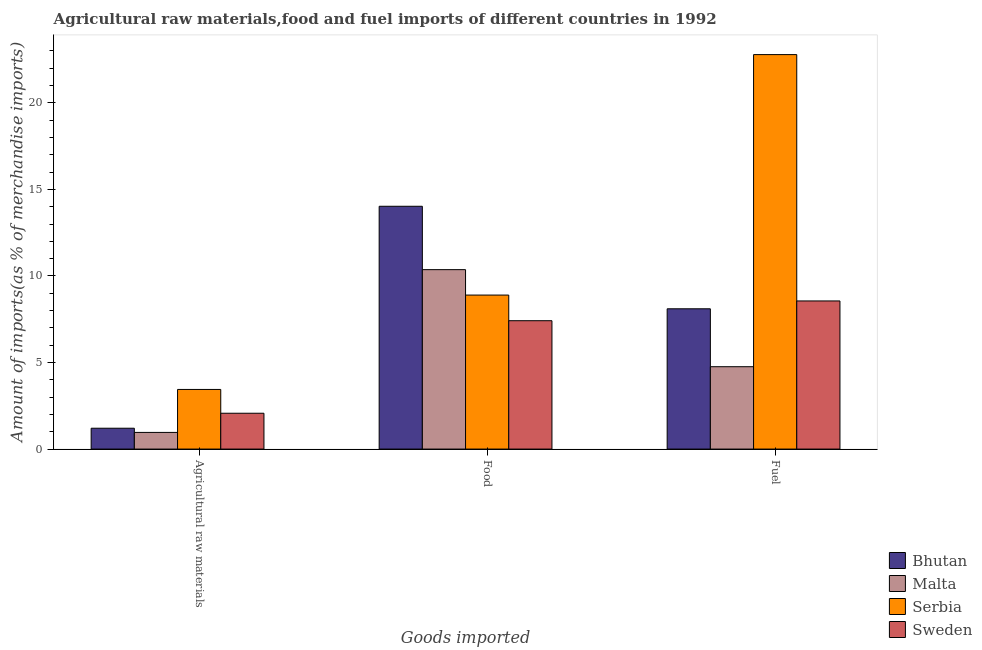How many different coloured bars are there?
Ensure brevity in your answer.  4. How many groups of bars are there?
Make the answer very short. 3. How many bars are there on the 2nd tick from the left?
Provide a succinct answer. 4. How many bars are there on the 3rd tick from the right?
Your response must be concise. 4. What is the label of the 2nd group of bars from the left?
Provide a succinct answer. Food. What is the percentage of raw materials imports in Sweden?
Your answer should be compact. 2.07. Across all countries, what is the maximum percentage of food imports?
Provide a short and direct response. 14.03. Across all countries, what is the minimum percentage of fuel imports?
Your answer should be very brief. 4.76. In which country was the percentage of fuel imports maximum?
Your response must be concise. Serbia. In which country was the percentage of raw materials imports minimum?
Provide a short and direct response. Malta. What is the total percentage of food imports in the graph?
Provide a succinct answer. 40.7. What is the difference between the percentage of fuel imports in Serbia and that in Sweden?
Your answer should be compact. 14.23. What is the difference between the percentage of raw materials imports in Sweden and the percentage of fuel imports in Malta?
Your response must be concise. -2.69. What is the average percentage of raw materials imports per country?
Give a very brief answer. 1.92. What is the difference between the percentage of food imports and percentage of raw materials imports in Serbia?
Your answer should be very brief. 5.45. In how many countries, is the percentage of fuel imports greater than 19 %?
Your response must be concise. 1. What is the ratio of the percentage of food imports in Sweden to that in Bhutan?
Ensure brevity in your answer.  0.53. What is the difference between the highest and the second highest percentage of food imports?
Offer a terse response. 3.66. What is the difference between the highest and the lowest percentage of fuel imports?
Your answer should be very brief. 18.03. Is the sum of the percentage of food imports in Sweden and Bhutan greater than the maximum percentage of raw materials imports across all countries?
Ensure brevity in your answer.  Yes. What does the 3rd bar from the left in Agricultural raw materials represents?
Make the answer very short. Serbia. What does the 3rd bar from the right in Fuel represents?
Provide a short and direct response. Malta. Is it the case that in every country, the sum of the percentage of raw materials imports and percentage of food imports is greater than the percentage of fuel imports?
Your response must be concise. No. How many bars are there?
Make the answer very short. 12. How many countries are there in the graph?
Offer a terse response. 4. Are the values on the major ticks of Y-axis written in scientific E-notation?
Provide a succinct answer. No. How many legend labels are there?
Provide a short and direct response. 4. What is the title of the graph?
Offer a very short reply. Agricultural raw materials,food and fuel imports of different countries in 1992. Does "Europe(developing only)" appear as one of the legend labels in the graph?
Ensure brevity in your answer.  No. What is the label or title of the X-axis?
Make the answer very short. Goods imported. What is the label or title of the Y-axis?
Your response must be concise. Amount of imports(as % of merchandise imports). What is the Amount of imports(as % of merchandise imports) of Bhutan in Agricultural raw materials?
Your answer should be very brief. 1.2. What is the Amount of imports(as % of merchandise imports) of Malta in Agricultural raw materials?
Ensure brevity in your answer.  0.96. What is the Amount of imports(as % of merchandise imports) in Serbia in Agricultural raw materials?
Provide a short and direct response. 3.44. What is the Amount of imports(as % of merchandise imports) in Sweden in Agricultural raw materials?
Ensure brevity in your answer.  2.07. What is the Amount of imports(as % of merchandise imports) in Bhutan in Food?
Offer a terse response. 14.03. What is the Amount of imports(as % of merchandise imports) in Malta in Food?
Give a very brief answer. 10.36. What is the Amount of imports(as % of merchandise imports) in Serbia in Food?
Make the answer very short. 8.9. What is the Amount of imports(as % of merchandise imports) of Sweden in Food?
Ensure brevity in your answer.  7.42. What is the Amount of imports(as % of merchandise imports) in Bhutan in Fuel?
Your response must be concise. 8.1. What is the Amount of imports(as % of merchandise imports) in Malta in Fuel?
Provide a succinct answer. 4.76. What is the Amount of imports(as % of merchandise imports) in Serbia in Fuel?
Ensure brevity in your answer.  22.79. What is the Amount of imports(as % of merchandise imports) in Sweden in Fuel?
Provide a succinct answer. 8.56. Across all Goods imported, what is the maximum Amount of imports(as % of merchandise imports) in Bhutan?
Your answer should be compact. 14.03. Across all Goods imported, what is the maximum Amount of imports(as % of merchandise imports) of Malta?
Provide a short and direct response. 10.36. Across all Goods imported, what is the maximum Amount of imports(as % of merchandise imports) in Serbia?
Keep it short and to the point. 22.79. Across all Goods imported, what is the maximum Amount of imports(as % of merchandise imports) in Sweden?
Ensure brevity in your answer.  8.56. Across all Goods imported, what is the minimum Amount of imports(as % of merchandise imports) in Bhutan?
Ensure brevity in your answer.  1.2. Across all Goods imported, what is the minimum Amount of imports(as % of merchandise imports) of Malta?
Keep it short and to the point. 0.96. Across all Goods imported, what is the minimum Amount of imports(as % of merchandise imports) of Serbia?
Make the answer very short. 3.44. Across all Goods imported, what is the minimum Amount of imports(as % of merchandise imports) of Sweden?
Your answer should be very brief. 2.07. What is the total Amount of imports(as % of merchandise imports) in Bhutan in the graph?
Your response must be concise. 23.33. What is the total Amount of imports(as % of merchandise imports) in Malta in the graph?
Provide a succinct answer. 16.08. What is the total Amount of imports(as % of merchandise imports) of Serbia in the graph?
Make the answer very short. 35.13. What is the total Amount of imports(as % of merchandise imports) in Sweden in the graph?
Ensure brevity in your answer.  18.04. What is the difference between the Amount of imports(as % of merchandise imports) in Bhutan in Agricultural raw materials and that in Food?
Give a very brief answer. -12.82. What is the difference between the Amount of imports(as % of merchandise imports) of Malta in Agricultural raw materials and that in Food?
Provide a short and direct response. -9.4. What is the difference between the Amount of imports(as % of merchandise imports) in Serbia in Agricultural raw materials and that in Food?
Keep it short and to the point. -5.45. What is the difference between the Amount of imports(as % of merchandise imports) of Sweden in Agricultural raw materials and that in Food?
Provide a short and direct response. -5.35. What is the difference between the Amount of imports(as % of merchandise imports) of Bhutan in Agricultural raw materials and that in Fuel?
Offer a terse response. -6.9. What is the difference between the Amount of imports(as % of merchandise imports) in Malta in Agricultural raw materials and that in Fuel?
Keep it short and to the point. -3.8. What is the difference between the Amount of imports(as % of merchandise imports) of Serbia in Agricultural raw materials and that in Fuel?
Provide a succinct answer. -19.34. What is the difference between the Amount of imports(as % of merchandise imports) in Sweden in Agricultural raw materials and that in Fuel?
Provide a short and direct response. -6.49. What is the difference between the Amount of imports(as % of merchandise imports) of Bhutan in Food and that in Fuel?
Your answer should be compact. 5.92. What is the difference between the Amount of imports(as % of merchandise imports) of Malta in Food and that in Fuel?
Give a very brief answer. 5.61. What is the difference between the Amount of imports(as % of merchandise imports) in Serbia in Food and that in Fuel?
Ensure brevity in your answer.  -13.89. What is the difference between the Amount of imports(as % of merchandise imports) of Sweden in Food and that in Fuel?
Your answer should be compact. -1.14. What is the difference between the Amount of imports(as % of merchandise imports) of Bhutan in Agricultural raw materials and the Amount of imports(as % of merchandise imports) of Malta in Food?
Give a very brief answer. -9.16. What is the difference between the Amount of imports(as % of merchandise imports) in Bhutan in Agricultural raw materials and the Amount of imports(as % of merchandise imports) in Serbia in Food?
Provide a short and direct response. -7.69. What is the difference between the Amount of imports(as % of merchandise imports) in Bhutan in Agricultural raw materials and the Amount of imports(as % of merchandise imports) in Sweden in Food?
Ensure brevity in your answer.  -6.21. What is the difference between the Amount of imports(as % of merchandise imports) of Malta in Agricultural raw materials and the Amount of imports(as % of merchandise imports) of Serbia in Food?
Offer a terse response. -7.93. What is the difference between the Amount of imports(as % of merchandise imports) in Malta in Agricultural raw materials and the Amount of imports(as % of merchandise imports) in Sweden in Food?
Offer a very short reply. -6.45. What is the difference between the Amount of imports(as % of merchandise imports) of Serbia in Agricultural raw materials and the Amount of imports(as % of merchandise imports) of Sweden in Food?
Your answer should be compact. -3.97. What is the difference between the Amount of imports(as % of merchandise imports) in Bhutan in Agricultural raw materials and the Amount of imports(as % of merchandise imports) in Malta in Fuel?
Your response must be concise. -3.55. What is the difference between the Amount of imports(as % of merchandise imports) of Bhutan in Agricultural raw materials and the Amount of imports(as % of merchandise imports) of Serbia in Fuel?
Keep it short and to the point. -21.58. What is the difference between the Amount of imports(as % of merchandise imports) of Bhutan in Agricultural raw materials and the Amount of imports(as % of merchandise imports) of Sweden in Fuel?
Ensure brevity in your answer.  -7.35. What is the difference between the Amount of imports(as % of merchandise imports) of Malta in Agricultural raw materials and the Amount of imports(as % of merchandise imports) of Serbia in Fuel?
Your answer should be very brief. -21.82. What is the difference between the Amount of imports(as % of merchandise imports) of Malta in Agricultural raw materials and the Amount of imports(as % of merchandise imports) of Sweden in Fuel?
Give a very brief answer. -7.59. What is the difference between the Amount of imports(as % of merchandise imports) of Serbia in Agricultural raw materials and the Amount of imports(as % of merchandise imports) of Sweden in Fuel?
Provide a succinct answer. -5.11. What is the difference between the Amount of imports(as % of merchandise imports) in Bhutan in Food and the Amount of imports(as % of merchandise imports) in Malta in Fuel?
Ensure brevity in your answer.  9.27. What is the difference between the Amount of imports(as % of merchandise imports) of Bhutan in Food and the Amount of imports(as % of merchandise imports) of Serbia in Fuel?
Your answer should be compact. -8.76. What is the difference between the Amount of imports(as % of merchandise imports) of Bhutan in Food and the Amount of imports(as % of merchandise imports) of Sweden in Fuel?
Keep it short and to the point. 5.47. What is the difference between the Amount of imports(as % of merchandise imports) of Malta in Food and the Amount of imports(as % of merchandise imports) of Serbia in Fuel?
Your answer should be very brief. -12.42. What is the difference between the Amount of imports(as % of merchandise imports) of Malta in Food and the Amount of imports(as % of merchandise imports) of Sweden in Fuel?
Your answer should be very brief. 1.81. What is the difference between the Amount of imports(as % of merchandise imports) of Serbia in Food and the Amount of imports(as % of merchandise imports) of Sweden in Fuel?
Keep it short and to the point. 0.34. What is the average Amount of imports(as % of merchandise imports) in Bhutan per Goods imported?
Your answer should be very brief. 7.78. What is the average Amount of imports(as % of merchandise imports) in Malta per Goods imported?
Give a very brief answer. 5.36. What is the average Amount of imports(as % of merchandise imports) of Serbia per Goods imported?
Your answer should be very brief. 11.71. What is the average Amount of imports(as % of merchandise imports) in Sweden per Goods imported?
Your answer should be very brief. 6.01. What is the difference between the Amount of imports(as % of merchandise imports) in Bhutan and Amount of imports(as % of merchandise imports) in Malta in Agricultural raw materials?
Ensure brevity in your answer.  0.24. What is the difference between the Amount of imports(as % of merchandise imports) of Bhutan and Amount of imports(as % of merchandise imports) of Serbia in Agricultural raw materials?
Ensure brevity in your answer.  -2.24. What is the difference between the Amount of imports(as % of merchandise imports) in Bhutan and Amount of imports(as % of merchandise imports) in Sweden in Agricultural raw materials?
Give a very brief answer. -0.87. What is the difference between the Amount of imports(as % of merchandise imports) of Malta and Amount of imports(as % of merchandise imports) of Serbia in Agricultural raw materials?
Your answer should be compact. -2.48. What is the difference between the Amount of imports(as % of merchandise imports) in Malta and Amount of imports(as % of merchandise imports) in Sweden in Agricultural raw materials?
Offer a terse response. -1.11. What is the difference between the Amount of imports(as % of merchandise imports) in Serbia and Amount of imports(as % of merchandise imports) in Sweden in Agricultural raw materials?
Offer a terse response. 1.37. What is the difference between the Amount of imports(as % of merchandise imports) of Bhutan and Amount of imports(as % of merchandise imports) of Malta in Food?
Ensure brevity in your answer.  3.66. What is the difference between the Amount of imports(as % of merchandise imports) in Bhutan and Amount of imports(as % of merchandise imports) in Serbia in Food?
Ensure brevity in your answer.  5.13. What is the difference between the Amount of imports(as % of merchandise imports) of Bhutan and Amount of imports(as % of merchandise imports) of Sweden in Food?
Ensure brevity in your answer.  6.61. What is the difference between the Amount of imports(as % of merchandise imports) in Malta and Amount of imports(as % of merchandise imports) in Serbia in Food?
Your response must be concise. 1.47. What is the difference between the Amount of imports(as % of merchandise imports) of Malta and Amount of imports(as % of merchandise imports) of Sweden in Food?
Offer a very short reply. 2.95. What is the difference between the Amount of imports(as % of merchandise imports) in Serbia and Amount of imports(as % of merchandise imports) in Sweden in Food?
Your answer should be very brief. 1.48. What is the difference between the Amount of imports(as % of merchandise imports) in Bhutan and Amount of imports(as % of merchandise imports) in Malta in Fuel?
Provide a succinct answer. 3.35. What is the difference between the Amount of imports(as % of merchandise imports) of Bhutan and Amount of imports(as % of merchandise imports) of Serbia in Fuel?
Provide a succinct answer. -14.68. What is the difference between the Amount of imports(as % of merchandise imports) in Bhutan and Amount of imports(as % of merchandise imports) in Sweden in Fuel?
Give a very brief answer. -0.45. What is the difference between the Amount of imports(as % of merchandise imports) of Malta and Amount of imports(as % of merchandise imports) of Serbia in Fuel?
Provide a succinct answer. -18.03. What is the difference between the Amount of imports(as % of merchandise imports) of Malta and Amount of imports(as % of merchandise imports) of Sweden in Fuel?
Make the answer very short. -3.8. What is the difference between the Amount of imports(as % of merchandise imports) of Serbia and Amount of imports(as % of merchandise imports) of Sweden in Fuel?
Offer a very short reply. 14.23. What is the ratio of the Amount of imports(as % of merchandise imports) in Bhutan in Agricultural raw materials to that in Food?
Offer a very short reply. 0.09. What is the ratio of the Amount of imports(as % of merchandise imports) in Malta in Agricultural raw materials to that in Food?
Give a very brief answer. 0.09. What is the ratio of the Amount of imports(as % of merchandise imports) of Serbia in Agricultural raw materials to that in Food?
Make the answer very short. 0.39. What is the ratio of the Amount of imports(as % of merchandise imports) in Sweden in Agricultural raw materials to that in Food?
Your answer should be very brief. 0.28. What is the ratio of the Amount of imports(as % of merchandise imports) of Bhutan in Agricultural raw materials to that in Fuel?
Your answer should be very brief. 0.15. What is the ratio of the Amount of imports(as % of merchandise imports) in Malta in Agricultural raw materials to that in Fuel?
Offer a very short reply. 0.2. What is the ratio of the Amount of imports(as % of merchandise imports) of Serbia in Agricultural raw materials to that in Fuel?
Make the answer very short. 0.15. What is the ratio of the Amount of imports(as % of merchandise imports) of Sweden in Agricultural raw materials to that in Fuel?
Your answer should be very brief. 0.24. What is the ratio of the Amount of imports(as % of merchandise imports) of Bhutan in Food to that in Fuel?
Ensure brevity in your answer.  1.73. What is the ratio of the Amount of imports(as % of merchandise imports) of Malta in Food to that in Fuel?
Your response must be concise. 2.18. What is the ratio of the Amount of imports(as % of merchandise imports) of Serbia in Food to that in Fuel?
Provide a succinct answer. 0.39. What is the ratio of the Amount of imports(as % of merchandise imports) of Sweden in Food to that in Fuel?
Your answer should be very brief. 0.87. What is the difference between the highest and the second highest Amount of imports(as % of merchandise imports) in Bhutan?
Provide a succinct answer. 5.92. What is the difference between the highest and the second highest Amount of imports(as % of merchandise imports) of Malta?
Your answer should be compact. 5.61. What is the difference between the highest and the second highest Amount of imports(as % of merchandise imports) of Serbia?
Ensure brevity in your answer.  13.89. What is the difference between the highest and the second highest Amount of imports(as % of merchandise imports) of Sweden?
Offer a terse response. 1.14. What is the difference between the highest and the lowest Amount of imports(as % of merchandise imports) of Bhutan?
Offer a terse response. 12.82. What is the difference between the highest and the lowest Amount of imports(as % of merchandise imports) in Malta?
Offer a very short reply. 9.4. What is the difference between the highest and the lowest Amount of imports(as % of merchandise imports) of Serbia?
Keep it short and to the point. 19.34. What is the difference between the highest and the lowest Amount of imports(as % of merchandise imports) in Sweden?
Your answer should be compact. 6.49. 